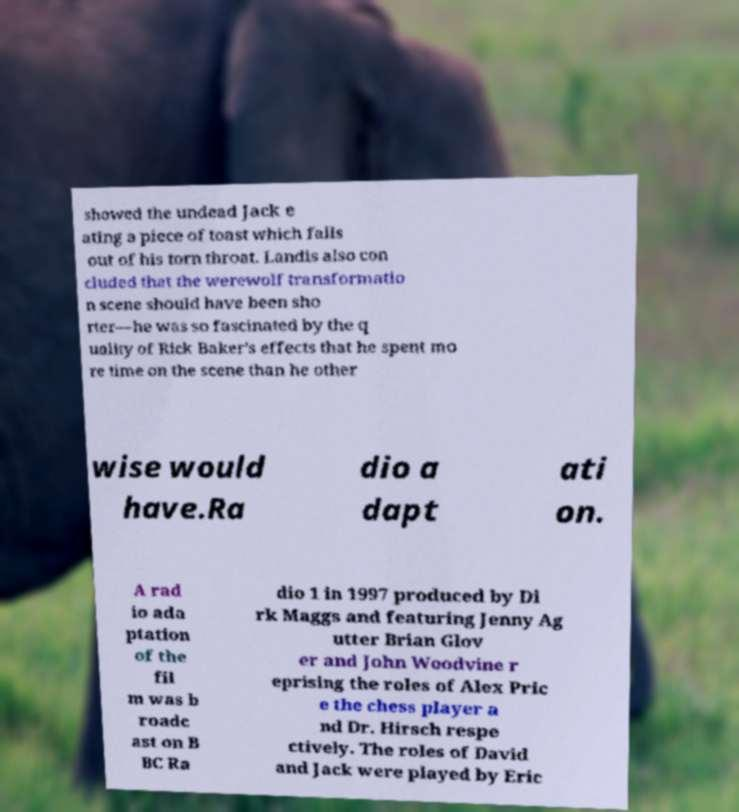Can you accurately transcribe the text from the provided image for me? showed the undead Jack e ating a piece of toast which falls out of his torn throat. Landis also con cluded that the werewolf transformatio n scene should have been sho rter—he was so fascinated by the q uality of Rick Baker's effects that he spent mo re time on the scene than he other wise would have.Ra dio a dapt ati on. A rad io ada ptation of the fil m was b roadc ast on B BC Ra dio 1 in 1997 produced by Di rk Maggs and featuring Jenny Ag utter Brian Glov er and John Woodvine r eprising the roles of Alex Pric e the chess player a nd Dr. Hirsch respe ctively. The roles of David and Jack were played by Eric 